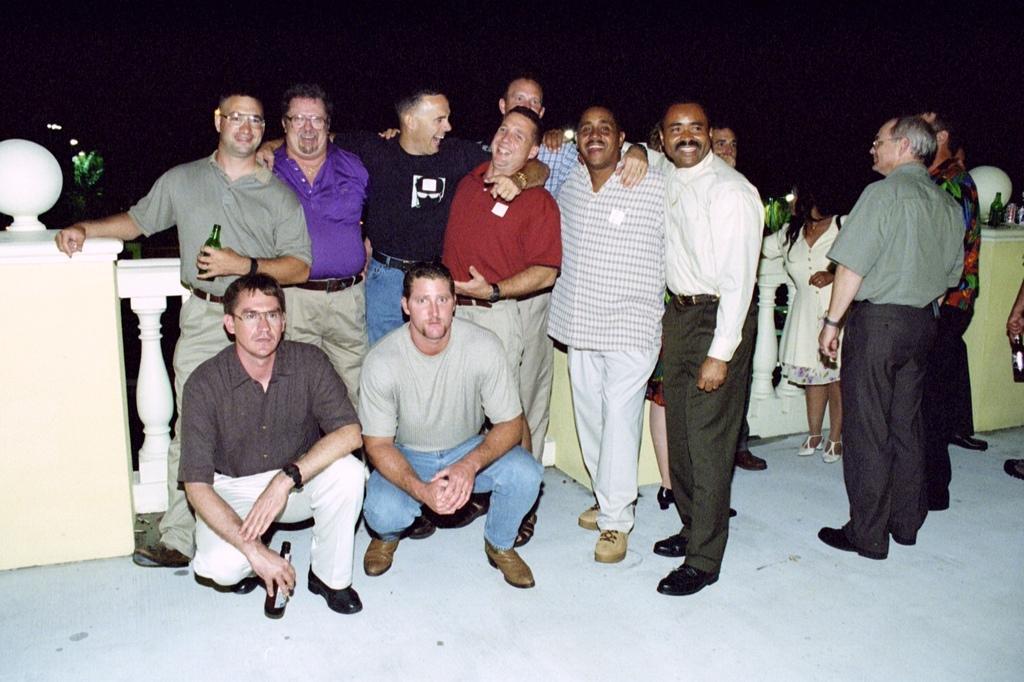Could you give a brief overview of what you see in this image? In this picture I can observe some men standing on the floor in the middle of the picture. Some of them are holding bottles in their hands. The background is completely dark. 